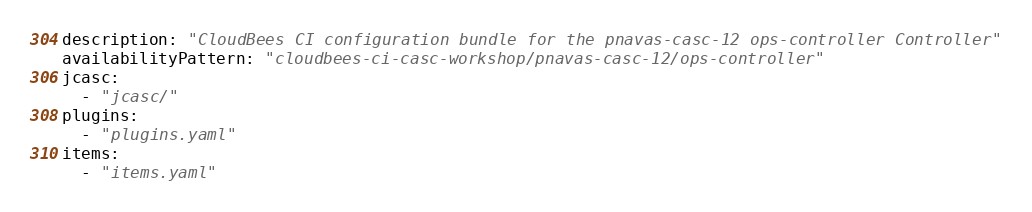Convert code to text. <code><loc_0><loc_0><loc_500><loc_500><_YAML_>description: "CloudBees CI configuration bundle for the pnavas-casc-12 ops-controller Controller"
availabilityPattern: "cloudbees-ci-casc-workshop/pnavas-casc-12/ops-controller"
jcasc:
  - "jcasc/"
plugins:
  - "plugins.yaml"
items:
  - "items.yaml"
</code> 